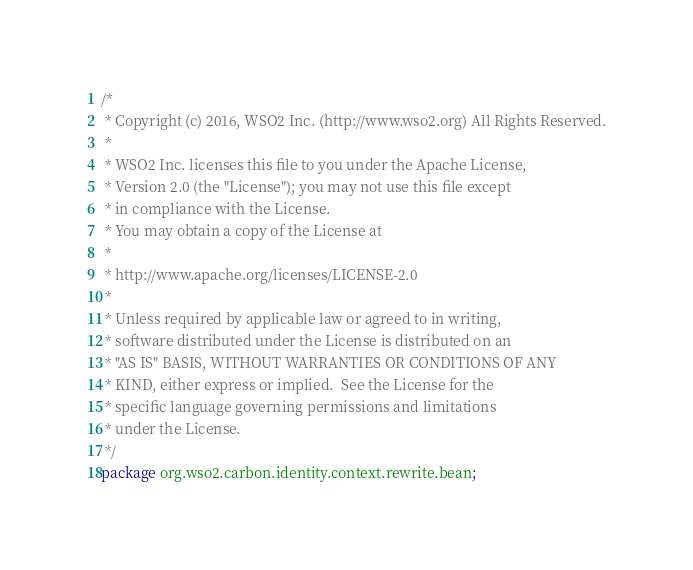<code> <loc_0><loc_0><loc_500><loc_500><_Java_>/*
 * Copyright (c) 2016, WSO2 Inc. (http://www.wso2.org) All Rights Reserved.
 *
 * WSO2 Inc. licenses this file to you under the Apache License,
 * Version 2.0 (the "License"); you may not use this file except
 * in compliance with the License.
 * You may obtain a copy of the License at
 *
 * http://www.apache.org/licenses/LICENSE-2.0
 *
 * Unless required by applicable law or agreed to in writing,
 * software distributed under the License is distributed on an
 * "AS IS" BASIS, WITHOUT WARRANTIES OR CONDITIONS OF ANY
 * KIND, either express or implied.  See the License for the
 * specific language governing permissions and limitations
 * under the License.
 */
package org.wso2.carbon.identity.context.rewrite.bean;
</code> 